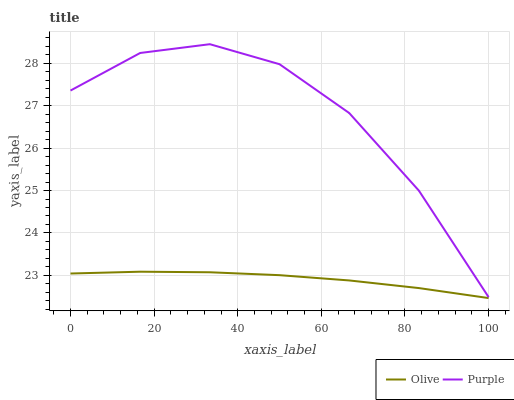Does Olive have the minimum area under the curve?
Answer yes or no. Yes. Does Purple have the maximum area under the curve?
Answer yes or no. Yes. Does Purple have the minimum area under the curve?
Answer yes or no. No. Is Olive the smoothest?
Answer yes or no. Yes. Is Purple the roughest?
Answer yes or no. Yes. Is Purple the smoothest?
Answer yes or no. No. Does Olive have the lowest value?
Answer yes or no. Yes. Does Purple have the lowest value?
Answer yes or no. No. Does Purple have the highest value?
Answer yes or no. Yes. Is Olive less than Purple?
Answer yes or no. Yes. Is Purple greater than Olive?
Answer yes or no. Yes. Does Olive intersect Purple?
Answer yes or no. No. 